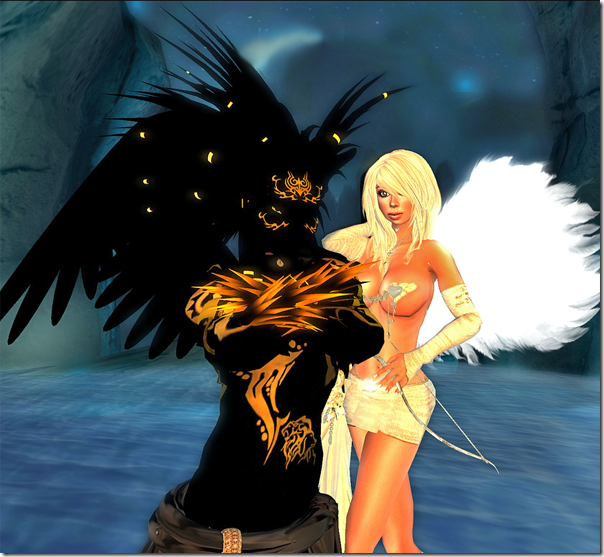Considering the details in the attire and accessories of the characters, what era or cultural influences might have inspired their design? Based on the attire and accessories of the characters, it is difficult to pinpoint a specific era or culture that directly inspired their design, as they represent a blend of various fantasy and mythological elements. However, the use of gold detailing and the ethereal appearance might draw from historical periods where ornate jewelry and embellishments were prevalent, such as the Baroque period. Additionally, the fantasy elements, such as the wings, might be inspired by various cultural mythologies where winged beings symbolize different aspects, such as angels in Western culture or mythical birds in Eastern legends. The overall design seems to be a creative fusion of historical luxury and mythical symbolism, crafted to create a fantastical ambiance rather than reflect a singular cultural influence. 